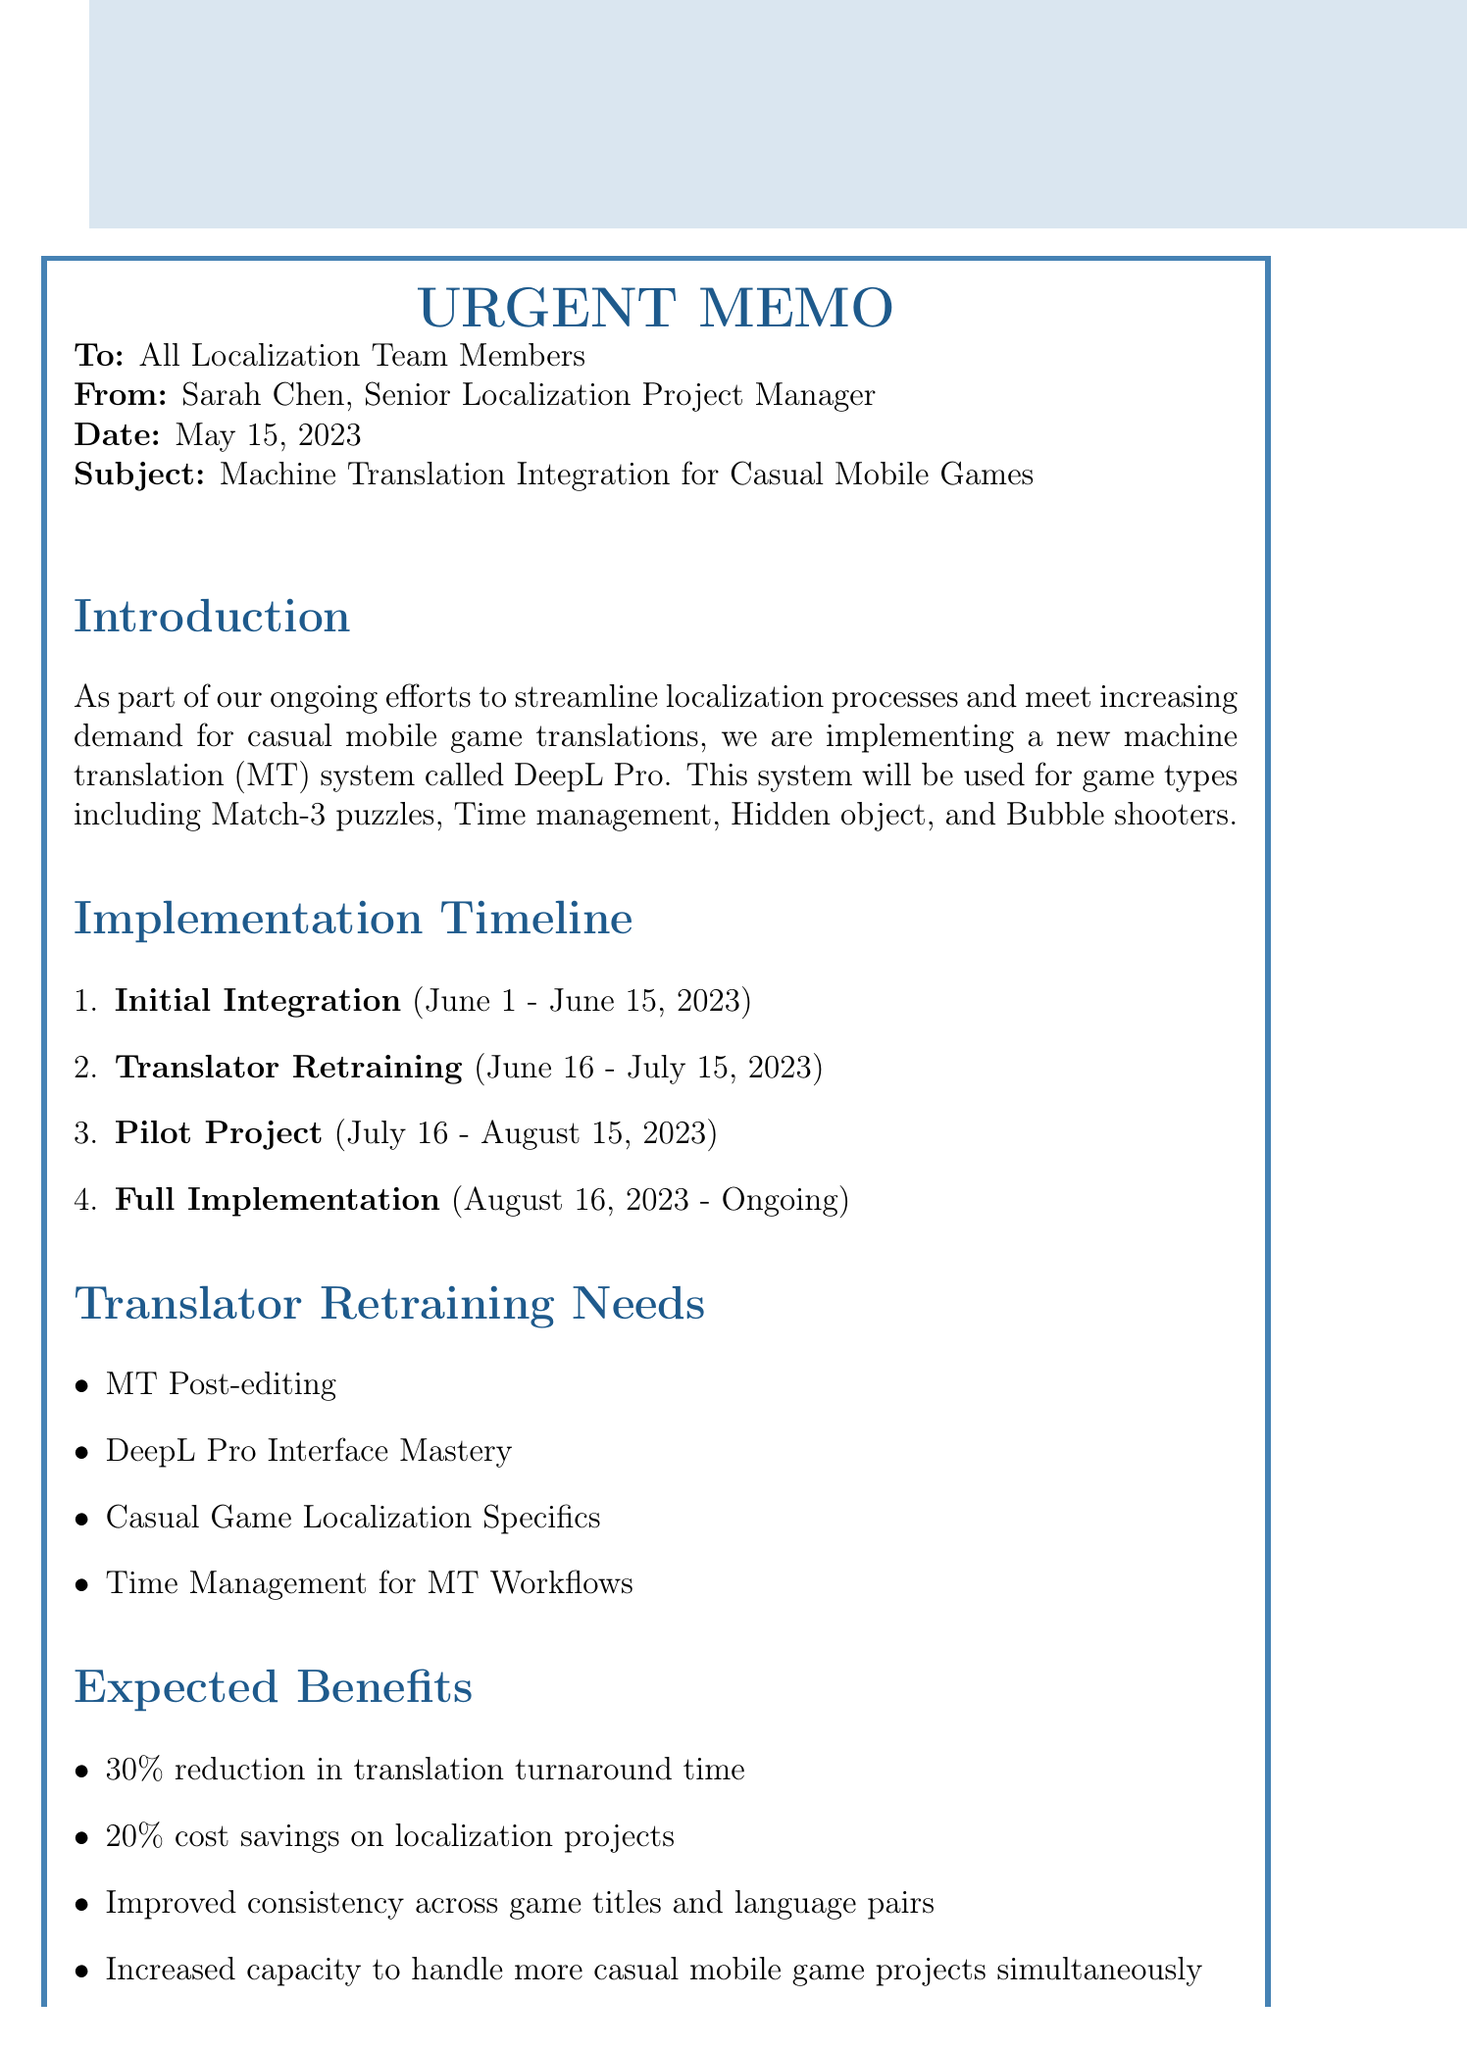What is the start date for the initial integration phase? The start date for the initial integration phase is explicitly stated in the document.
Answer: June 1, 2023 Who is the sender of the memo? The sender of the memo is mentioned in the header section.
Answer: Sarah Chen, Senior Localization Project Manager What will be used for the new machine translation system? The specific machine translation system is mentioned in the introduction.
Answer: DeepL Pro What is the duration of the translator retraining phase? The document specifies the start and end dates for the translator retraining phase, allowing us to calculate the duration.
Answer: June 16, 2023 - July 15, 2023 What is one expected benefit of the machine translation integration? The document lists several expected benefits, one of which answers this question.
Answer: 30% reduction in translation turnaround time Which casual mobile game will be selected for the pilot project? The memo describes the specific game selected for the pilot project.
Answer: Candy Crush Saga clone How many tasks are listed for the full implementation phase? The document includes a specific number of tasks within the full implementation section.
Answer: 3 What is required to prepare for the Q&A session with the DeepL representative? The next steps section outlines the need to prepare for the Q&A session.
Answer: Questions and concerns 